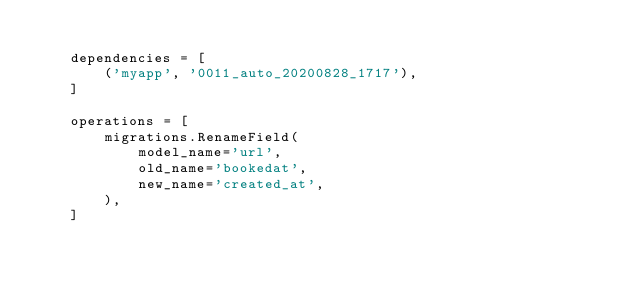<code> <loc_0><loc_0><loc_500><loc_500><_Python_>
    dependencies = [
        ('myapp', '0011_auto_20200828_1717'),
    ]

    operations = [
        migrations.RenameField(
            model_name='url',
            old_name='bookedat',
            new_name='created_at',
        ),
    ]
</code> 